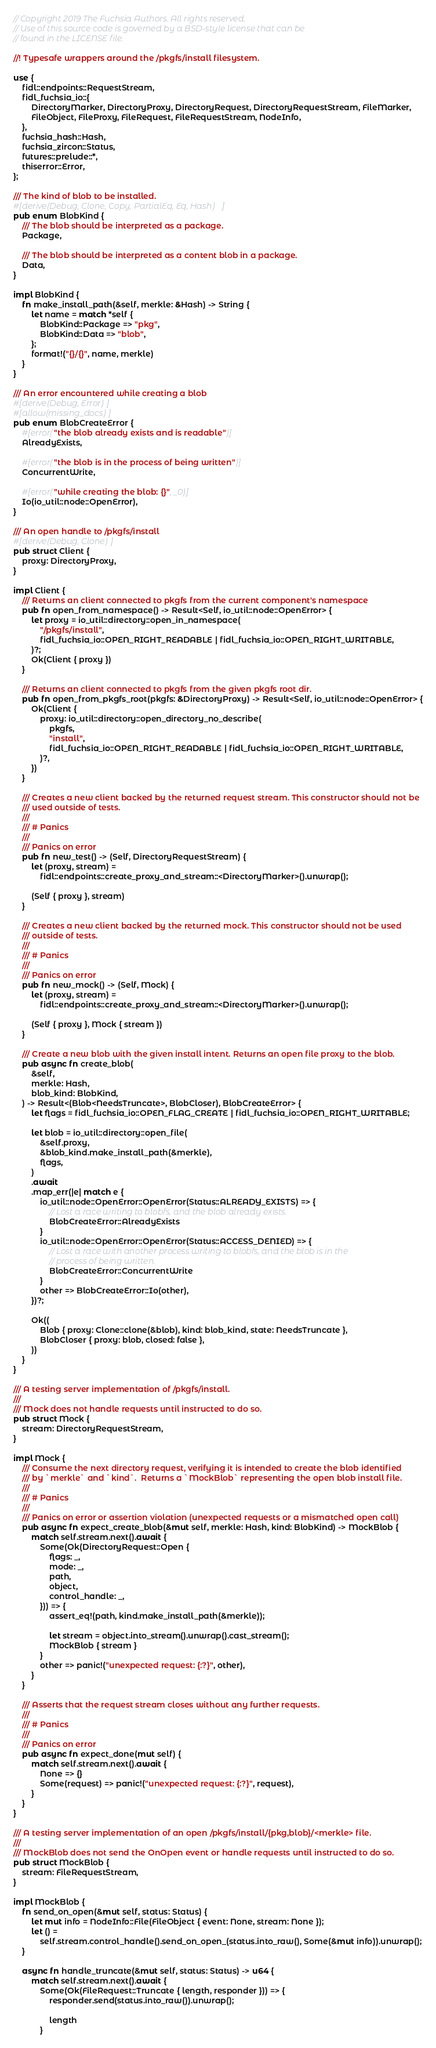Convert code to text. <code><loc_0><loc_0><loc_500><loc_500><_Rust_>// Copyright 2019 The Fuchsia Authors. All rights reserved.
// Use of this source code is governed by a BSD-style license that can be
// found in the LICENSE file.

//! Typesafe wrappers around the /pkgfs/install filesystem.

use {
    fidl::endpoints::RequestStream,
    fidl_fuchsia_io::{
        DirectoryMarker, DirectoryProxy, DirectoryRequest, DirectoryRequestStream, FileMarker,
        FileObject, FileProxy, FileRequest, FileRequestStream, NodeInfo,
    },
    fuchsia_hash::Hash,
    fuchsia_zircon::Status,
    futures::prelude::*,
    thiserror::Error,
};

/// The kind of blob to be installed.
#[derive(Debug, Clone, Copy, PartialEq, Eq, Hash)]
pub enum BlobKind {
    /// The blob should be interpreted as a package.
    Package,

    /// The blob should be interpreted as a content blob in a package.
    Data,
}

impl BlobKind {
    fn make_install_path(&self, merkle: &Hash) -> String {
        let name = match *self {
            BlobKind::Package => "pkg",
            BlobKind::Data => "blob",
        };
        format!("{}/{}", name, merkle)
    }
}

/// An error encountered while creating a blob
#[derive(Debug, Error)]
#[allow(missing_docs)]
pub enum BlobCreateError {
    #[error("the blob already exists and is readable")]
    AlreadyExists,

    #[error("the blob is in the process of being written")]
    ConcurrentWrite,

    #[error("while creating the blob: {}", _0)]
    Io(io_util::node::OpenError),
}

/// An open handle to /pkgfs/install
#[derive(Debug, Clone)]
pub struct Client {
    proxy: DirectoryProxy,
}

impl Client {
    /// Returns an client connected to pkgfs from the current component's namespace
    pub fn open_from_namespace() -> Result<Self, io_util::node::OpenError> {
        let proxy = io_util::directory::open_in_namespace(
            "/pkgfs/install",
            fidl_fuchsia_io::OPEN_RIGHT_READABLE | fidl_fuchsia_io::OPEN_RIGHT_WRITABLE,
        )?;
        Ok(Client { proxy })
    }

    /// Returns an client connected to pkgfs from the given pkgfs root dir.
    pub fn open_from_pkgfs_root(pkgfs: &DirectoryProxy) -> Result<Self, io_util::node::OpenError> {
        Ok(Client {
            proxy: io_util::directory::open_directory_no_describe(
                pkgfs,
                "install",
                fidl_fuchsia_io::OPEN_RIGHT_READABLE | fidl_fuchsia_io::OPEN_RIGHT_WRITABLE,
            )?,
        })
    }

    /// Creates a new client backed by the returned request stream. This constructor should not be
    /// used outside of tests.
    ///
    /// # Panics
    ///
    /// Panics on error
    pub fn new_test() -> (Self, DirectoryRequestStream) {
        let (proxy, stream) =
            fidl::endpoints::create_proxy_and_stream::<DirectoryMarker>().unwrap();

        (Self { proxy }, stream)
    }

    /// Creates a new client backed by the returned mock. This constructor should not be used
    /// outside of tests.
    ///
    /// # Panics
    ///
    /// Panics on error
    pub fn new_mock() -> (Self, Mock) {
        let (proxy, stream) =
            fidl::endpoints::create_proxy_and_stream::<DirectoryMarker>().unwrap();

        (Self { proxy }, Mock { stream })
    }

    /// Create a new blob with the given install intent. Returns an open file proxy to the blob.
    pub async fn create_blob(
        &self,
        merkle: Hash,
        blob_kind: BlobKind,
    ) -> Result<(Blob<NeedsTruncate>, BlobCloser), BlobCreateError> {
        let flags = fidl_fuchsia_io::OPEN_FLAG_CREATE | fidl_fuchsia_io::OPEN_RIGHT_WRITABLE;

        let blob = io_util::directory::open_file(
            &self.proxy,
            &blob_kind.make_install_path(&merkle),
            flags,
        )
        .await
        .map_err(|e| match e {
            io_util::node::OpenError::OpenError(Status::ALREADY_EXISTS) => {
                // Lost a race writing to blobfs, and the blob already exists.
                BlobCreateError::AlreadyExists
            }
            io_util::node::OpenError::OpenError(Status::ACCESS_DENIED) => {
                // Lost a race with another process writing to blobfs, and the blob is in the
                // process of being written.
                BlobCreateError::ConcurrentWrite
            }
            other => BlobCreateError::Io(other),
        })?;

        Ok((
            Blob { proxy: Clone::clone(&blob), kind: blob_kind, state: NeedsTruncate },
            BlobCloser { proxy: blob, closed: false },
        ))
    }
}

/// A testing server implementation of /pkgfs/install.
///
/// Mock does not handle requests until instructed to do so.
pub struct Mock {
    stream: DirectoryRequestStream,
}

impl Mock {
    /// Consume the next directory request, verifying it is intended to create the blob identified
    /// by `merkle` and `kind`.  Returns a `MockBlob` representing the open blob install file.
    ///
    /// # Panics
    ///
    /// Panics on error or assertion violation (unexpected requests or a mismatched open call)
    pub async fn expect_create_blob(&mut self, merkle: Hash, kind: BlobKind) -> MockBlob {
        match self.stream.next().await {
            Some(Ok(DirectoryRequest::Open {
                flags: _,
                mode: _,
                path,
                object,
                control_handle: _,
            })) => {
                assert_eq!(path, kind.make_install_path(&merkle));

                let stream = object.into_stream().unwrap().cast_stream();
                MockBlob { stream }
            }
            other => panic!("unexpected request: {:?}", other),
        }
    }

    /// Asserts that the request stream closes without any further requests.
    ///
    /// # Panics
    ///
    /// Panics on error
    pub async fn expect_done(mut self) {
        match self.stream.next().await {
            None => {}
            Some(request) => panic!("unexpected request: {:?}", request),
        }
    }
}

/// A testing server implementation of an open /pkgfs/install/{pkg,blob}/<merkle> file.
///
/// MockBlob does not send the OnOpen event or handle requests until instructed to do so.
pub struct MockBlob {
    stream: FileRequestStream,
}

impl MockBlob {
    fn send_on_open(&mut self, status: Status) {
        let mut info = NodeInfo::File(FileObject { event: None, stream: None });
        let () =
            self.stream.control_handle().send_on_open_(status.into_raw(), Some(&mut info)).unwrap();
    }

    async fn handle_truncate(&mut self, status: Status) -> u64 {
        match self.stream.next().await {
            Some(Ok(FileRequest::Truncate { length, responder })) => {
                responder.send(status.into_raw()).unwrap();

                length
            }</code> 